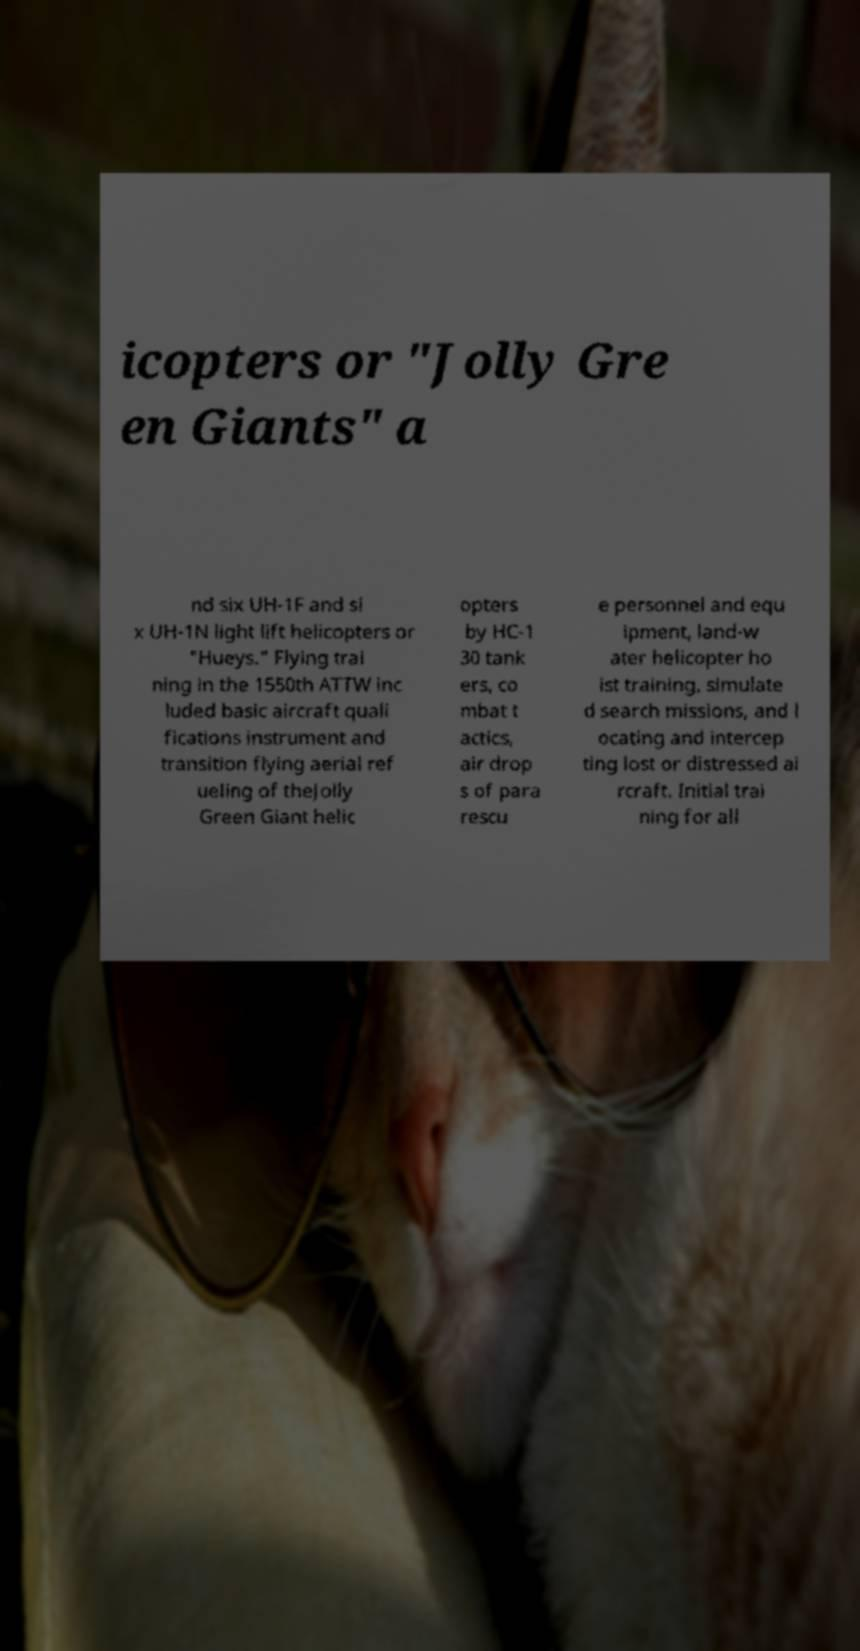Can you read and provide the text displayed in the image?This photo seems to have some interesting text. Can you extract and type it out for me? icopters or "Jolly Gre en Giants" a nd six UH-1F and si x UH-1N light lift helicopters or "Hueys." Flying trai ning in the 1550th ATTW inc luded basic aircraft quali fications instrument and transition flying aerial ref ueling of theJolly Green Giant helic opters by HC-1 30 tank ers, co mbat t actics, air drop s of para rescu e personnel and equ ipment, land-w ater helicopter ho ist training, simulate d search missions, and l ocating and intercep ting lost or distressed ai rcraft. Initial trai ning for all 